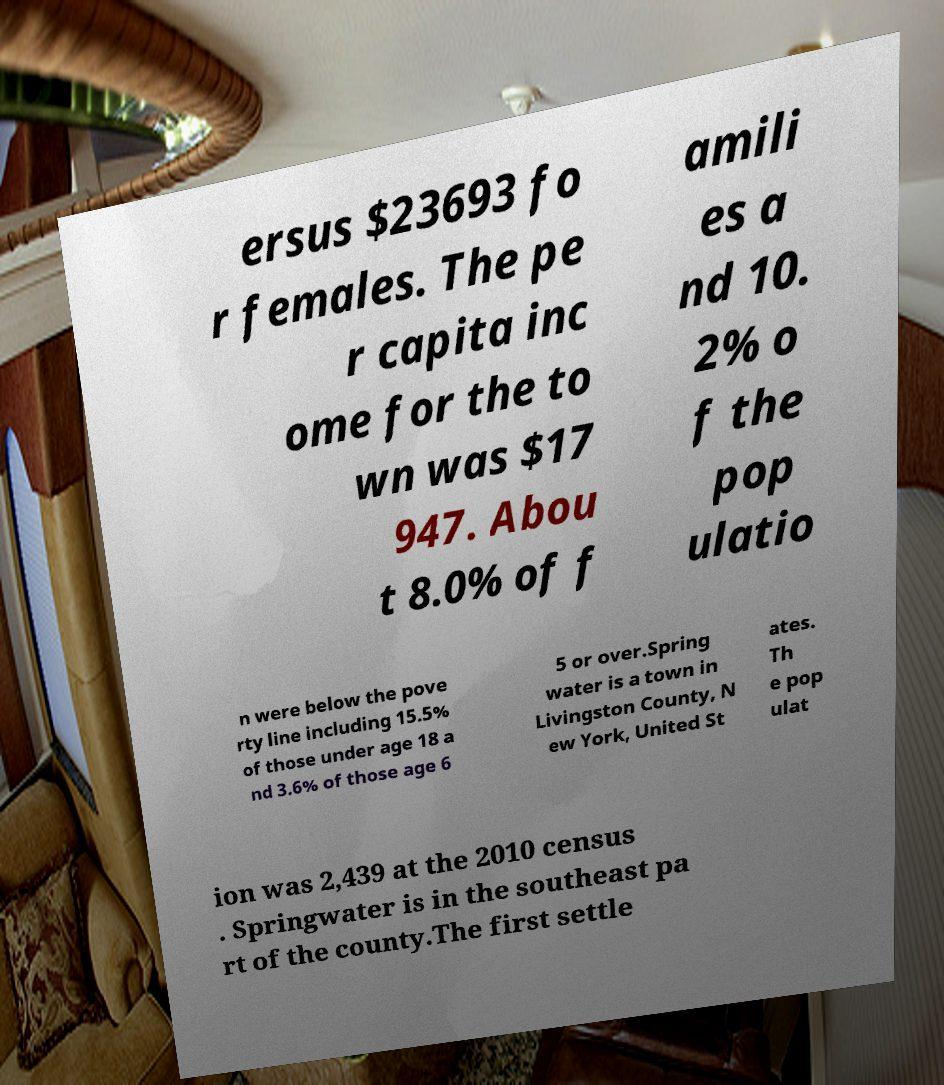For documentation purposes, I need the text within this image transcribed. Could you provide that? ersus $23693 fo r females. The pe r capita inc ome for the to wn was $17 947. Abou t 8.0% of f amili es a nd 10. 2% o f the pop ulatio n were below the pove rty line including 15.5% of those under age 18 a nd 3.6% of those age 6 5 or over.Spring water is a town in Livingston County, N ew York, United St ates. Th e pop ulat ion was 2,439 at the 2010 census . Springwater is in the southeast pa rt of the county.The first settle 